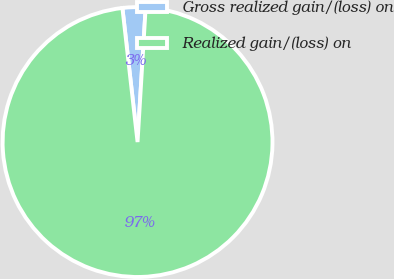<chart> <loc_0><loc_0><loc_500><loc_500><pie_chart><fcel>Gross realized gain/(loss) on<fcel>Realized gain/(loss) on<nl><fcel>2.75%<fcel>97.25%<nl></chart> 